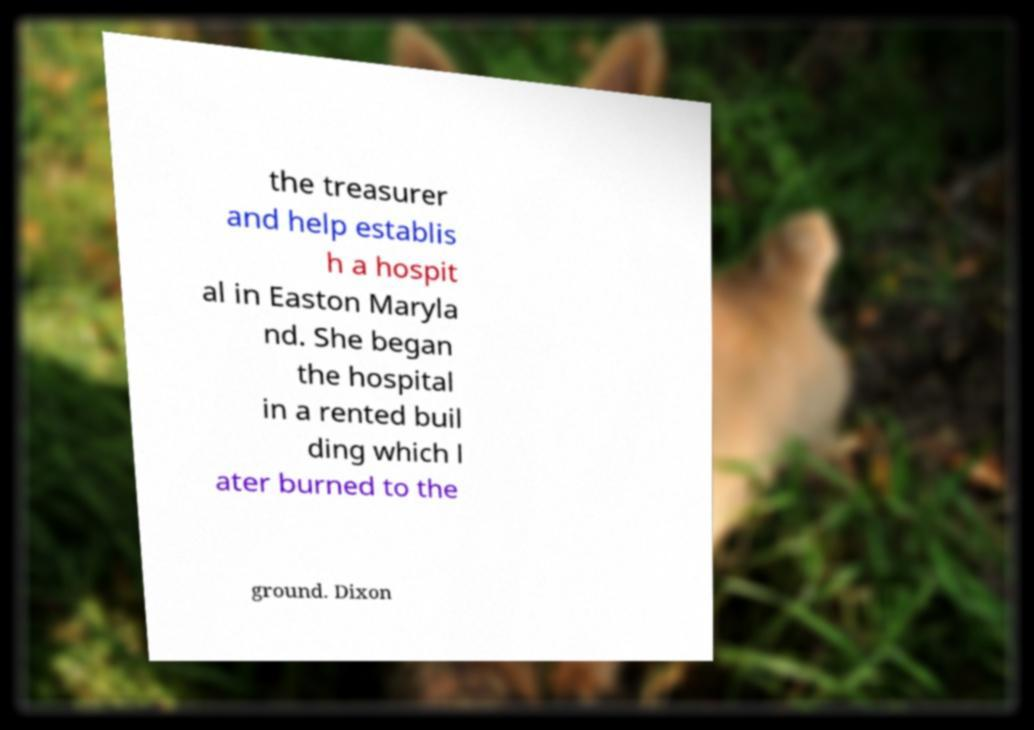Can you read and provide the text displayed in the image?This photo seems to have some interesting text. Can you extract and type it out for me? the treasurer and help establis h a hospit al in Easton Maryla nd. She began the hospital in a rented buil ding which l ater burned to the ground. Dixon 